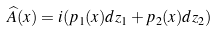Convert formula to latex. <formula><loc_0><loc_0><loc_500><loc_500>\widehat { A } ( x ) = i ( p _ { 1 } ( x ) d z _ { 1 } + p _ { 2 } ( x ) d z _ { 2 } )</formula> 